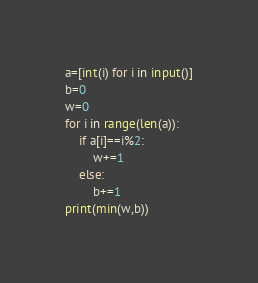<code> <loc_0><loc_0><loc_500><loc_500><_Python_>a=[int(i) for i in input()]
b=0
w=0
for i in range(len(a)):
    if a[i]==i%2:
        w+=1
    else:
        b+=1
print(min(w,b))</code> 